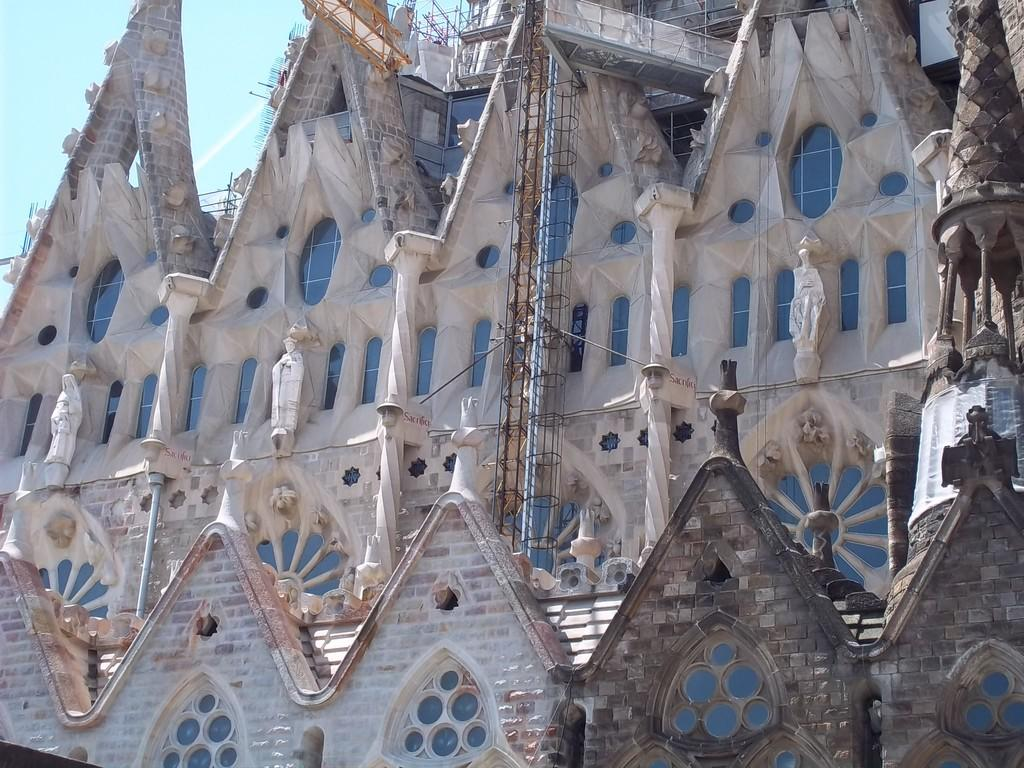What type of structure is present in the image? There is a building in the image. What can be seen on the building? The building has sculptures. What activity is happening at the building? Construction is taking place at the building. What is visible at the top of the image? The sky is visible at the top of the image. Where is the sheet used for the performance in the image? There is no sheet or performance present in the image; it features a building with construction and sculptures. What type of mine is visible in the image? There is no mine present in the image; it features a building with construction and sculptures. 